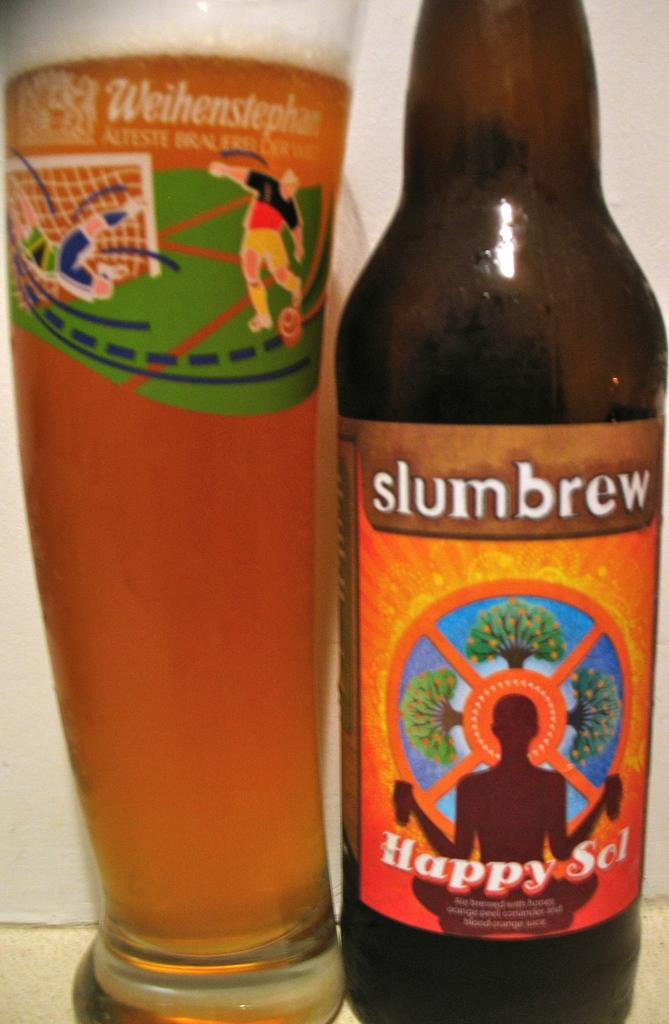What is the main object in the image? There is a wine bottle in the image. What can be said about the color of the wine bottle? The wine bottle is brown in color. Are there any additional markings or labels on the wine bottle? Yes, there is a sticker on the wine bottle. What else is related to wine in the image? There is a glass with wine in the image. Can you see any branches growing from the wine bottle in the image? No, there are no branches growing from the wine bottle in the image. Is there any fiction being read or written in the image? There is no reference to any fiction in the image; it primarily features a wine bottle and a glass of wine. 